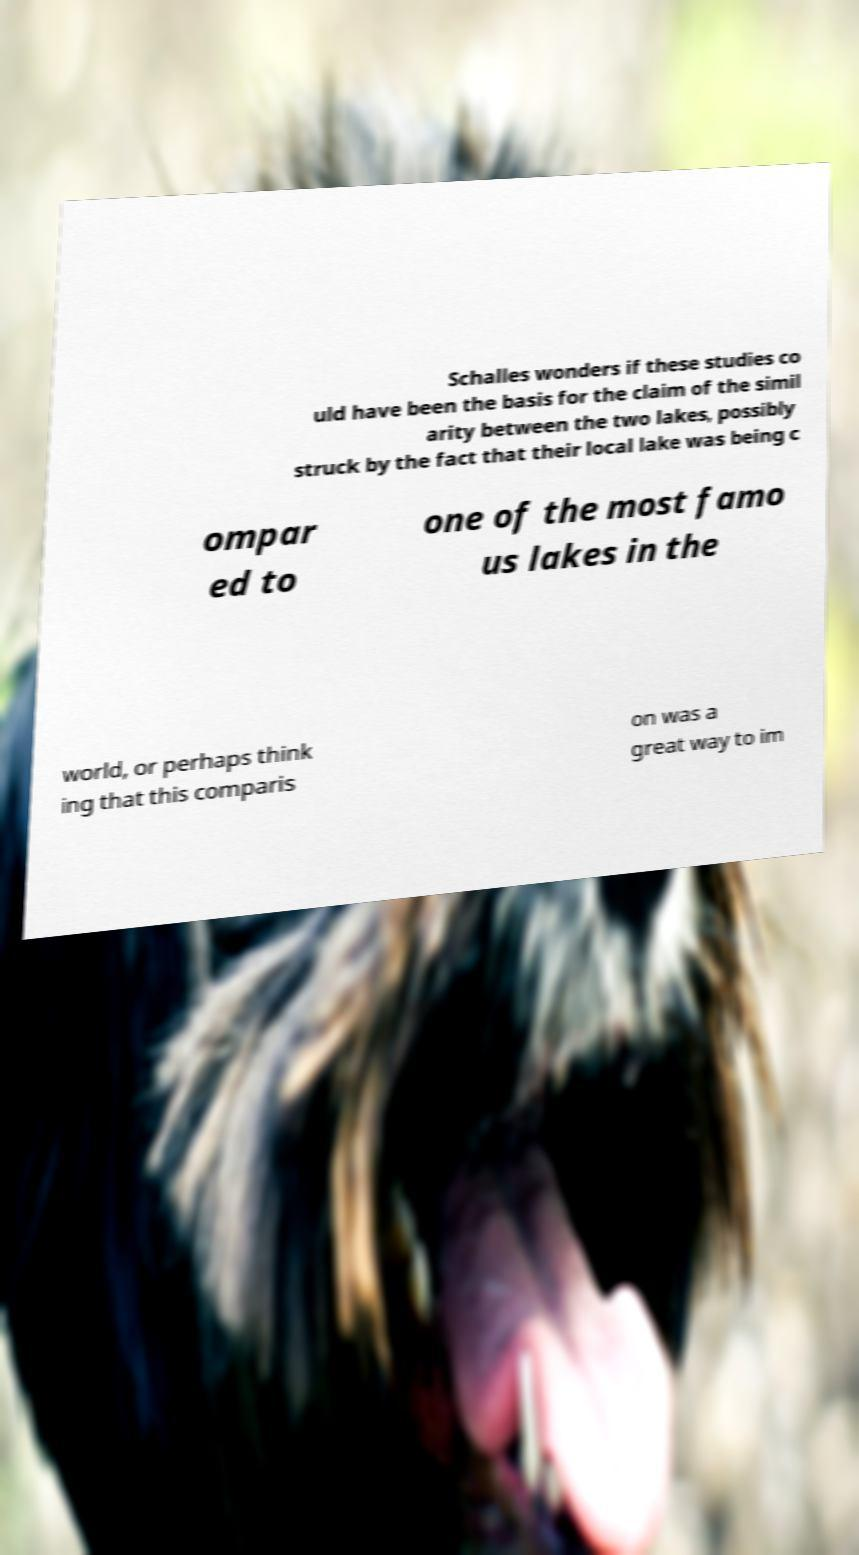For documentation purposes, I need the text within this image transcribed. Could you provide that? Schalles wonders if these studies co uld have been the basis for the claim of the simil arity between the two lakes, possibly struck by the fact that their local lake was being c ompar ed to one of the most famo us lakes in the world, or perhaps think ing that this comparis on was a great way to im 